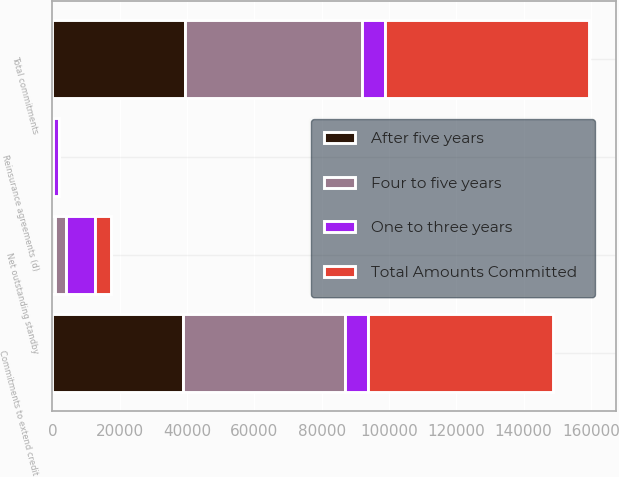Convert chart to OTSL. <chart><loc_0><loc_0><loc_500><loc_500><stacked_bar_chart><ecel><fcel>Commitments to extend credit<fcel>Net outstanding standby<fcel>Reinsurance agreements (d)<fcel>Total commitments<nl><fcel>One to three years<fcel>6786.5<fcel>8765<fcel>2010<fcel>6786.5<nl><fcel>Total Amounts Committed<fcel>54840<fcel>4808<fcel>7<fcel>60530<nl><fcel>Four to five years<fcel>48291<fcel>3323<fcel>20<fcel>52569<nl><fcel>After five years<fcel>38750<fcel>633<fcel>26<fcel>39476<nl></chart> 